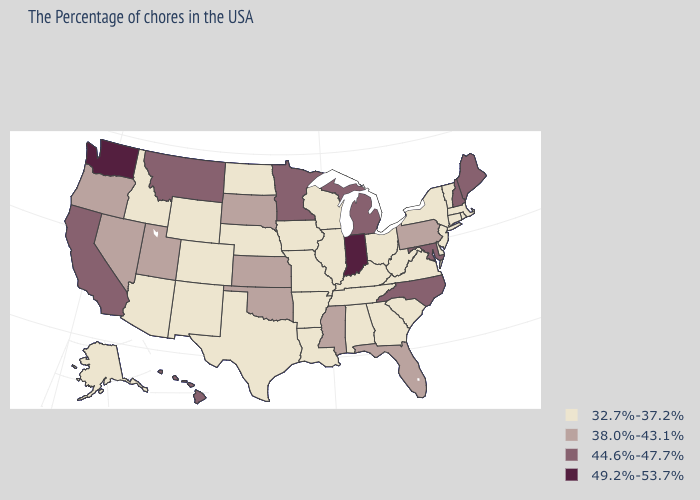Does Kentucky have a lower value than Missouri?
Quick response, please. No. Among the states that border Idaho , does Washington have the highest value?
Keep it brief. Yes. Which states have the highest value in the USA?
Quick response, please. Indiana, Washington. What is the value of Florida?
Short answer required. 38.0%-43.1%. What is the highest value in the West ?
Short answer required. 49.2%-53.7%. Name the states that have a value in the range 49.2%-53.7%?
Be succinct. Indiana, Washington. Among the states that border West Virginia , does Ohio have the lowest value?
Concise answer only. Yes. What is the value of Pennsylvania?
Short answer required. 38.0%-43.1%. What is the value of California?
Answer briefly. 44.6%-47.7%. What is the value of Oregon?
Write a very short answer. 38.0%-43.1%. What is the highest value in states that border New Hampshire?
Write a very short answer. 44.6%-47.7%. What is the value of North Dakota?
Short answer required. 32.7%-37.2%. What is the value of Florida?
Answer briefly. 38.0%-43.1%. Name the states that have a value in the range 44.6%-47.7%?
Quick response, please. Maine, New Hampshire, Maryland, North Carolina, Michigan, Minnesota, Montana, California, Hawaii. Among the states that border Oregon , which have the lowest value?
Concise answer only. Idaho. 